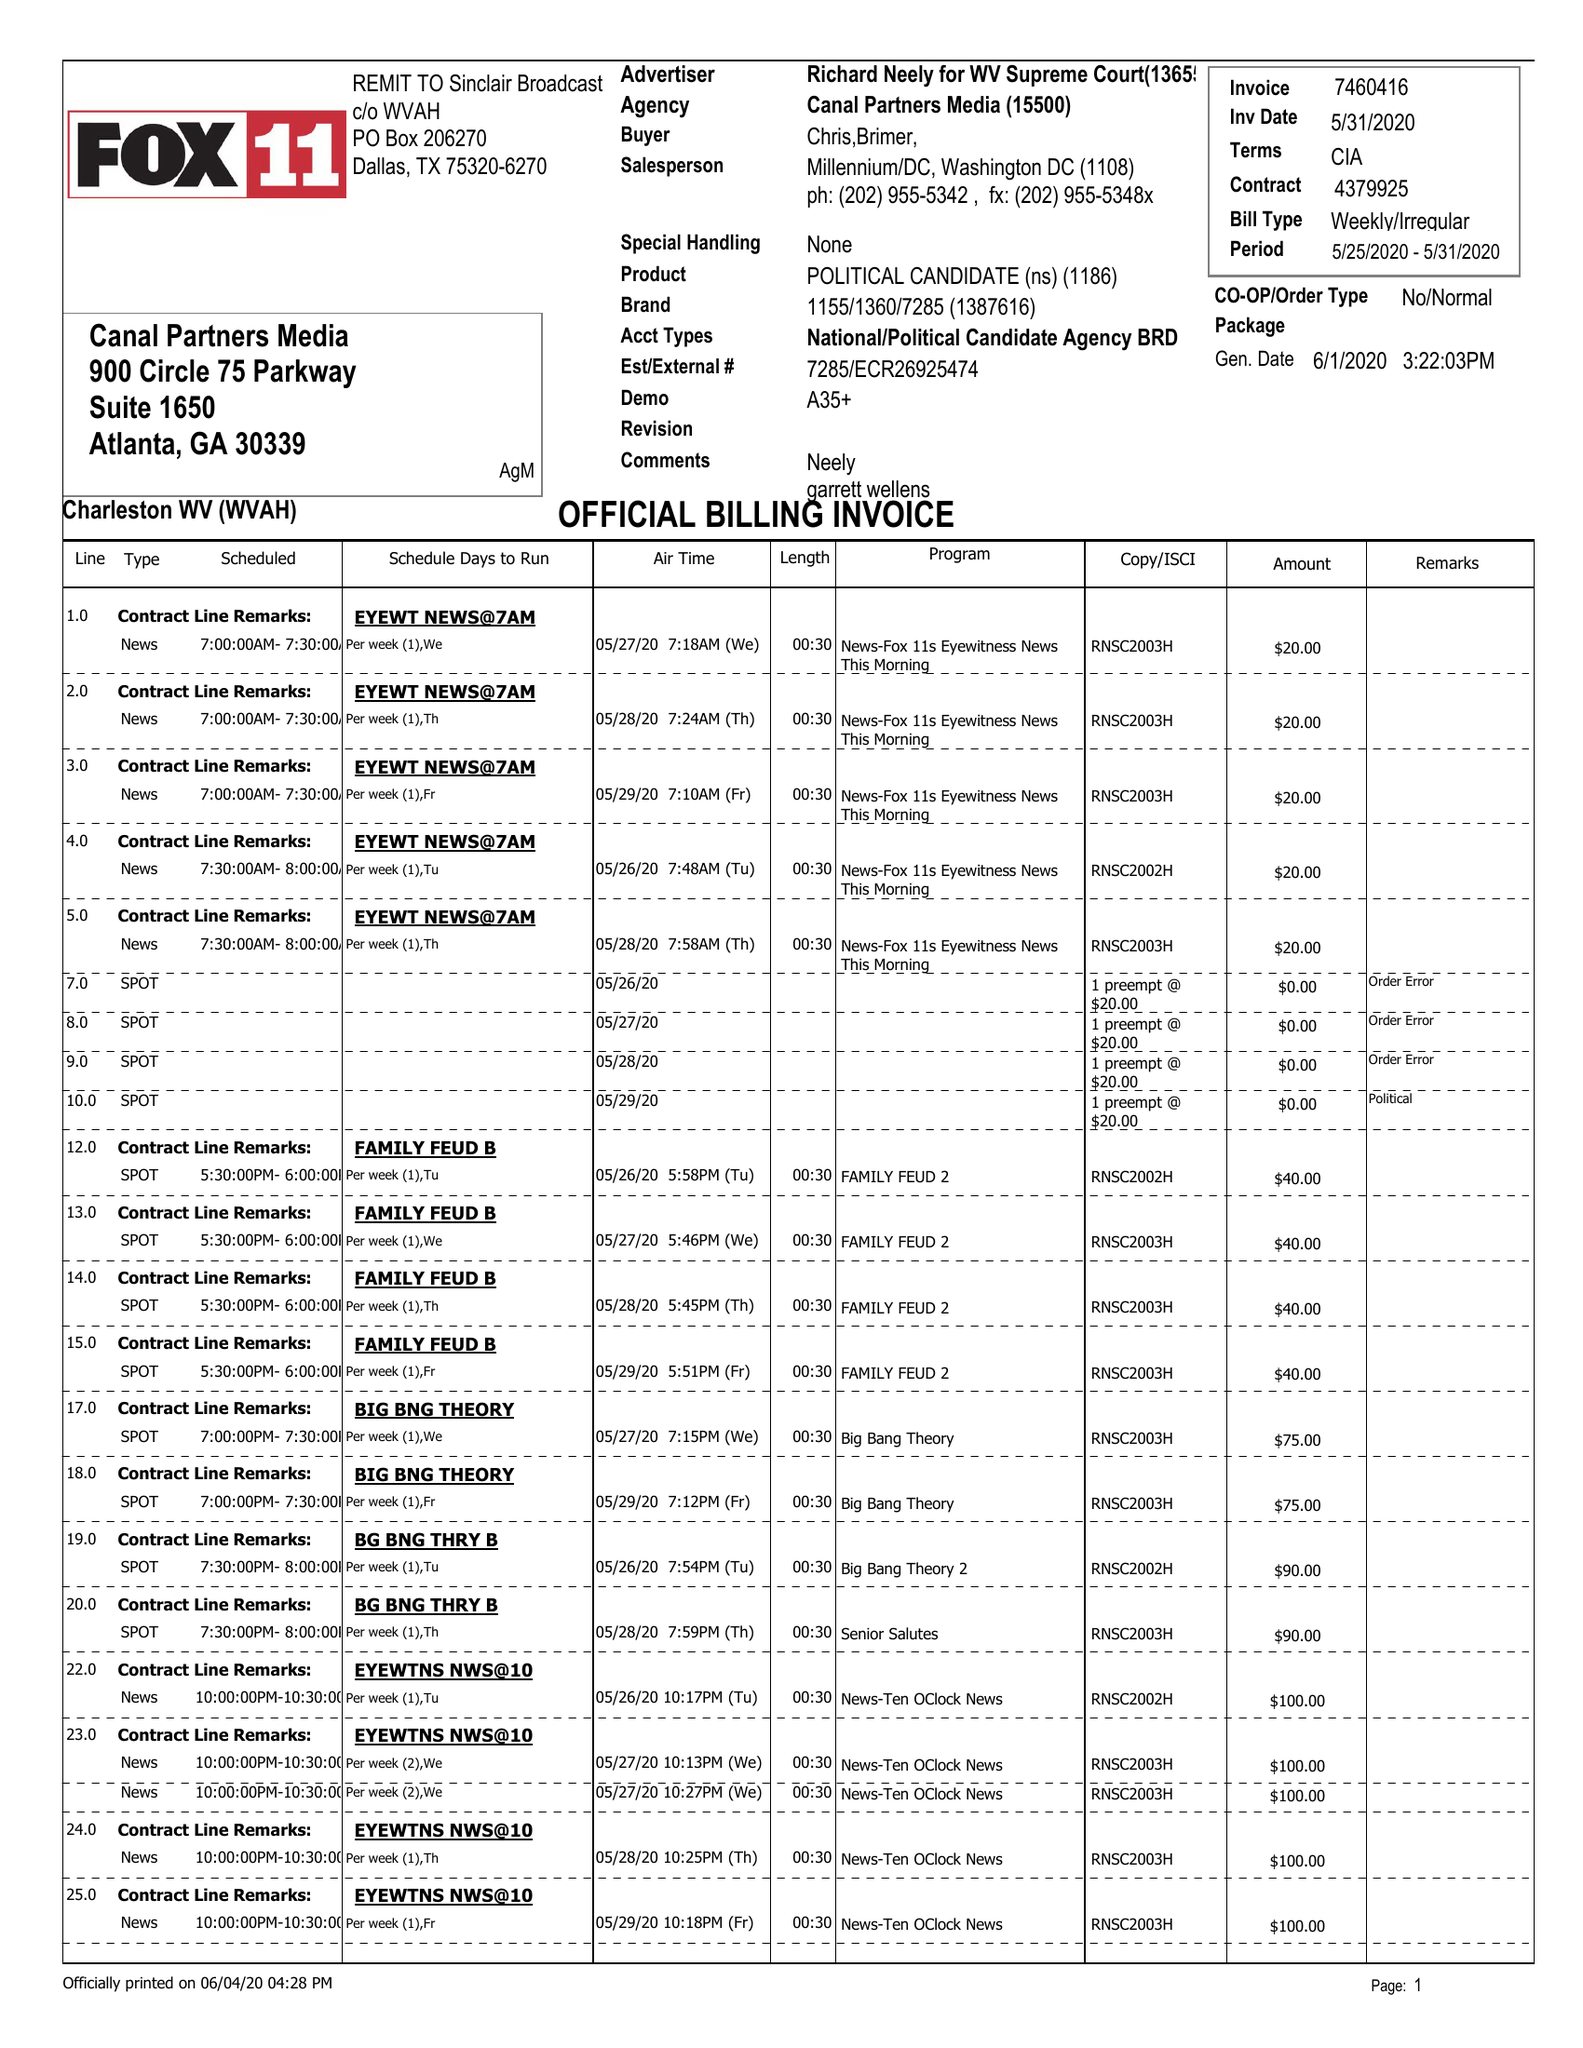What is the value for the gross_amount?
Answer the question using a single word or phrase. 1555.00 